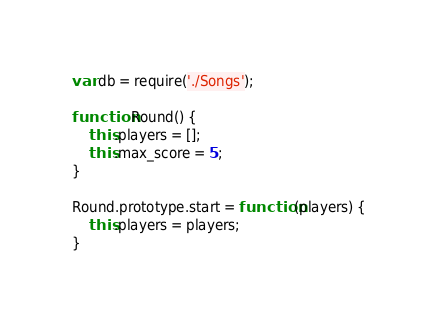Convert code to text. <code><loc_0><loc_0><loc_500><loc_500><_JavaScript_>var db = require('./Songs');

function Round() {
	this.players = [];
	this.max_score = 5;
}

Round.prototype.start = function(players) {
	this.players = players;
}</code> 